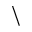<formula> <loc_0><loc_0><loc_500><loc_500>\</formula> 